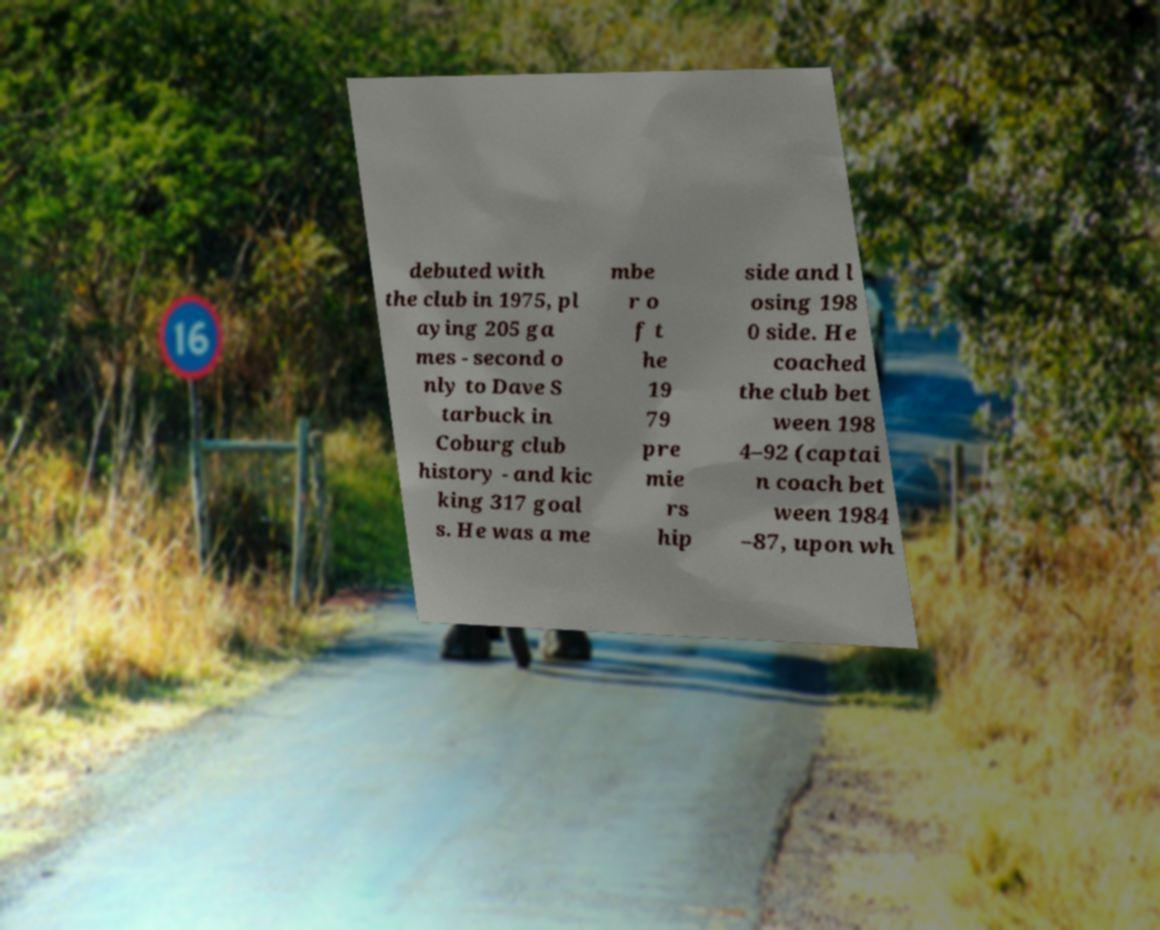Please identify and transcribe the text found in this image. debuted with the club in 1975, pl aying 205 ga mes - second o nly to Dave S tarbuck in Coburg club history - and kic king 317 goal s. He was a me mbe r o f t he 19 79 pre mie rs hip side and l osing 198 0 side. He coached the club bet ween 198 4–92 (captai n coach bet ween 1984 –87, upon wh 